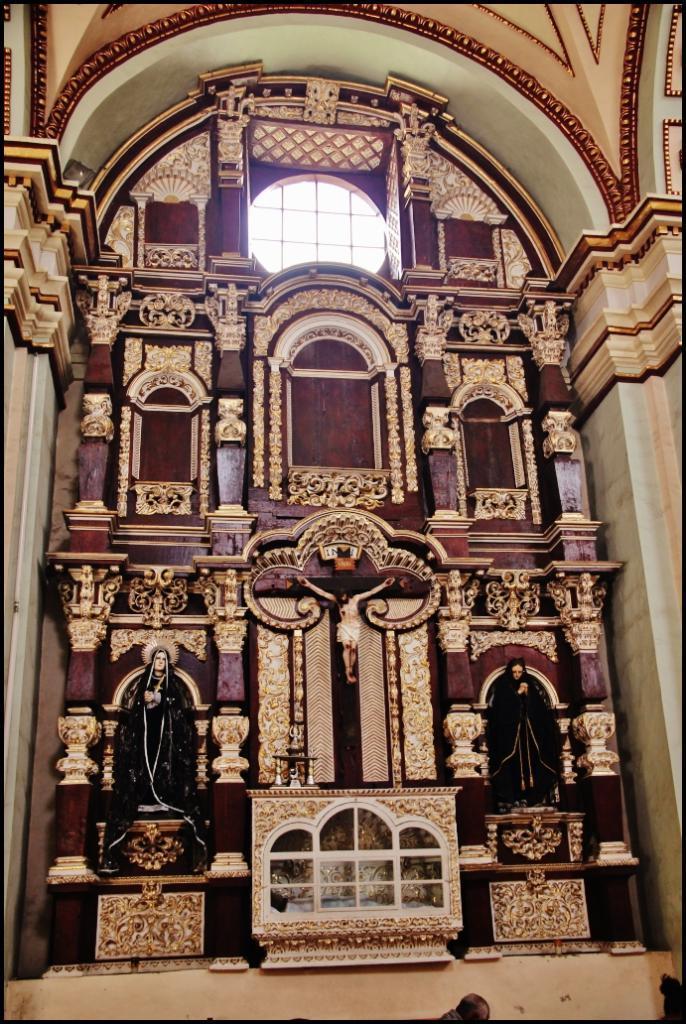How would you summarize this image in a sentence or two? In the center of the image there is a statue. On the right and left side of the image we can see statues. In the background there is a wall, pillars and window. 